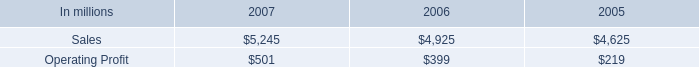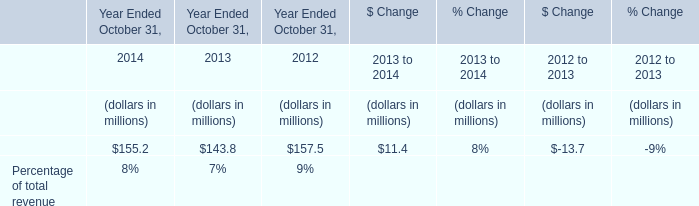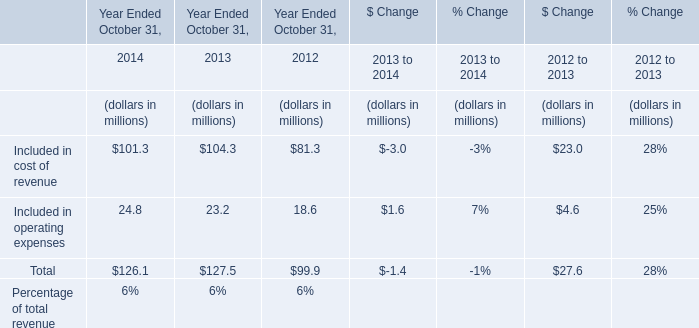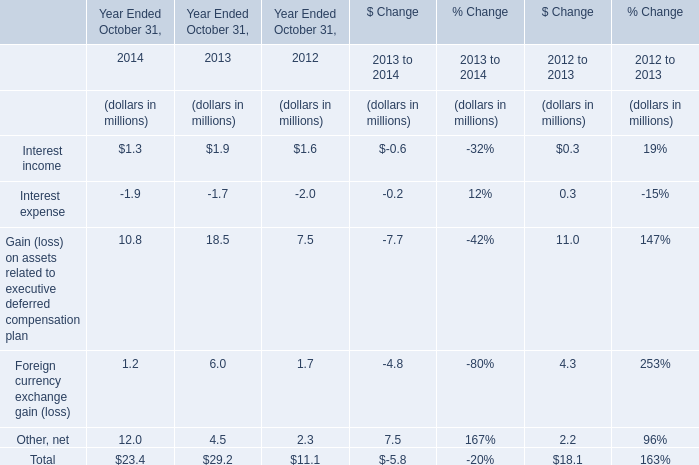what percentage of industrial packaging sales where represented by european industrial packaging net sales in 2006? 
Computations: ((1 * 1000) / 4925)
Answer: 0.20305. 